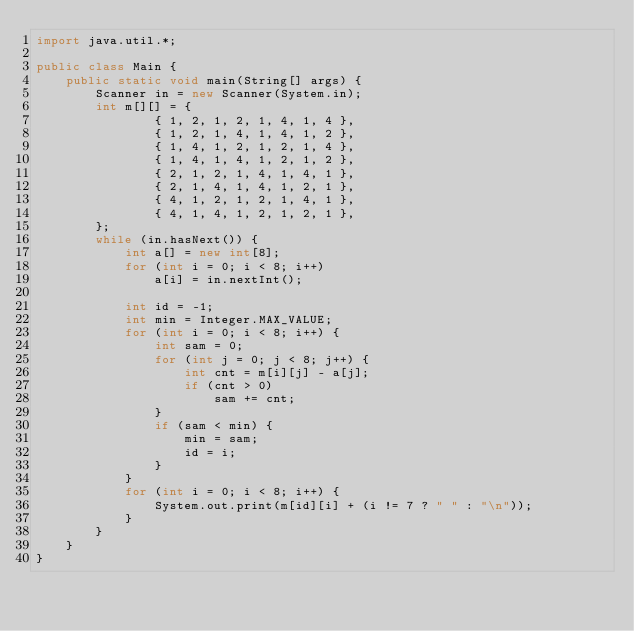<code> <loc_0><loc_0><loc_500><loc_500><_Java_>import java.util.*;

public class Main {
    public static void main(String[] args) {
        Scanner in = new Scanner(System.in);
        int m[][] = {
                { 1, 2, 1, 2, 1, 4, 1, 4 },
                { 1, 2, 1, 4, 1, 4, 1, 2 },
                { 1, 4, 1, 2, 1, 2, 1, 4 },
                { 1, 4, 1, 4, 1, 2, 1, 2 },
                { 2, 1, 2, 1, 4, 1, 4, 1 },
                { 2, 1, 4, 1, 4, 1, 2, 1 },
                { 4, 1, 2, 1, 2, 1, 4, 1 },
                { 4, 1, 4, 1, 2, 1, 2, 1 },
        };
        while (in.hasNext()) {
            int a[] = new int[8];
            for (int i = 0; i < 8; i++)
                a[i] = in.nextInt();

            int id = -1;
            int min = Integer.MAX_VALUE;
            for (int i = 0; i < 8; i++) {
                int sam = 0;
                for (int j = 0; j < 8; j++) {
                    int cnt = m[i][j] - a[j];
                    if (cnt > 0)
                        sam += cnt;
                }
                if (sam < min) {
                    min = sam;
                    id = i;
                }
            }
            for (int i = 0; i < 8; i++) {
                System.out.print(m[id][i] + (i != 7 ? " " : "\n"));
            }
        }
    }
}
</code> 